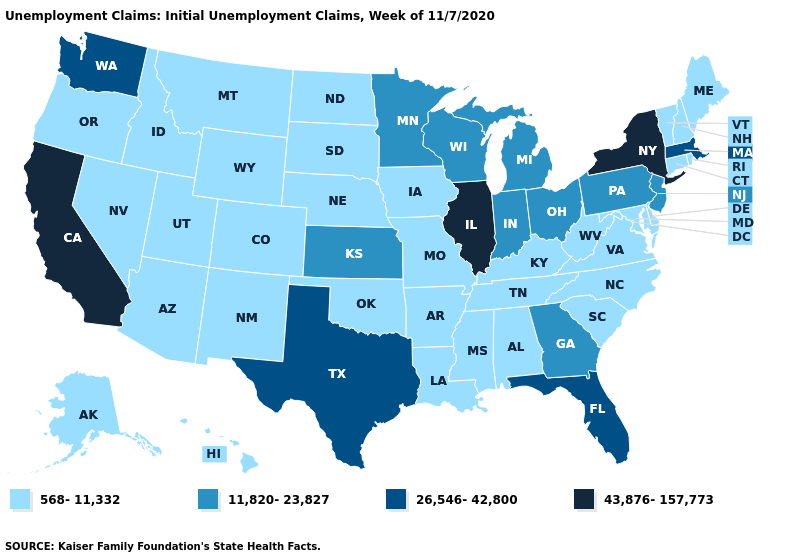What is the value of Missouri?
Quick response, please. 568-11,332. What is the value of Maryland?
Write a very short answer. 568-11,332. Does Alaska have the lowest value in the USA?
Be succinct. Yes. Does Wisconsin have a higher value than South Carolina?
Give a very brief answer. Yes. What is the lowest value in the South?
Quick response, please. 568-11,332. Does Missouri have the lowest value in the USA?
Short answer required. Yes. Which states have the highest value in the USA?
Give a very brief answer. California, Illinois, New York. Does Maine have the same value as Minnesota?
Write a very short answer. No. What is the value of Maine?
Keep it brief. 568-11,332. Does Minnesota have the same value as Georgia?
Keep it brief. Yes. What is the value of West Virginia?
Keep it brief. 568-11,332. Which states have the lowest value in the USA?
Be succinct. Alabama, Alaska, Arizona, Arkansas, Colorado, Connecticut, Delaware, Hawaii, Idaho, Iowa, Kentucky, Louisiana, Maine, Maryland, Mississippi, Missouri, Montana, Nebraska, Nevada, New Hampshire, New Mexico, North Carolina, North Dakota, Oklahoma, Oregon, Rhode Island, South Carolina, South Dakota, Tennessee, Utah, Vermont, Virginia, West Virginia, Wyoming. Which states have the lowest value in the Northeast?
Give a very brief answer. Connecticut, Maine, New Hampshire, Rhode Island, Vermont. Name the states that have a value in the range 11,820-23,827?
Keep it brief. Georgia, Indiana, Kansas, Michigan, Minnesota, New Jersey, Ohio, Pennsylvania, Wisconsin. Does California have the lowest value in the USA?
Write a very short answer. No. 